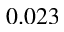<formula> <loc_0><loc_0><loc_500><loc_500>0 . 0 2 3</formula> 